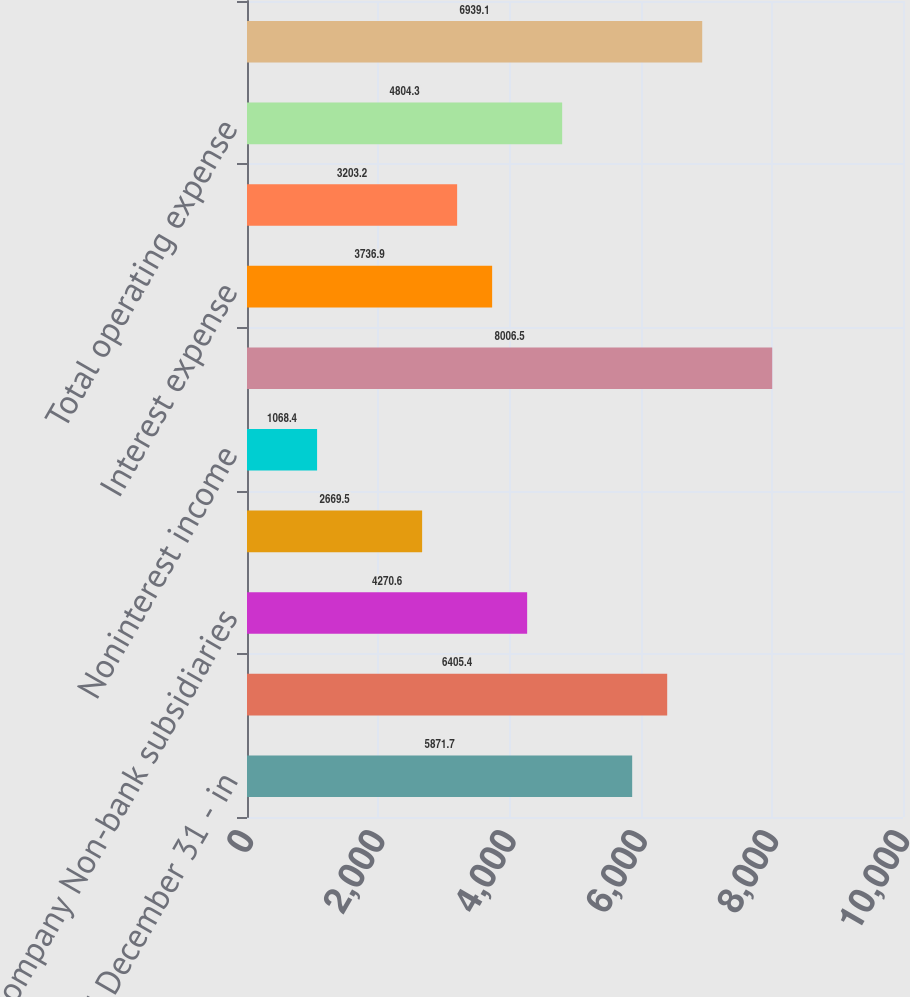Convert chart. <chart><loc_0><loc_0><loc_500><loc_500><bar_chart><fcel>Year ended December 31 - in<fcel>Dividends from Bank<fcel>company Non-bank subsidiaries<fcel>Interest income<fcel>Noninterest income<fcel>Total operating revenue<fcel>Interest expense<fcel>Other expense<fcel>Total operating expense<fcel>Income before income taxes and<nl><fcel>5871.7<fcel>6405.4<fcel>4270.6<fcel>2669.5<fcel>1068.4<fcel>8006.5<fcel>3736.9<fcel>3203.2<fcel>4804.3<fcel>6939.1<nl></chart> 